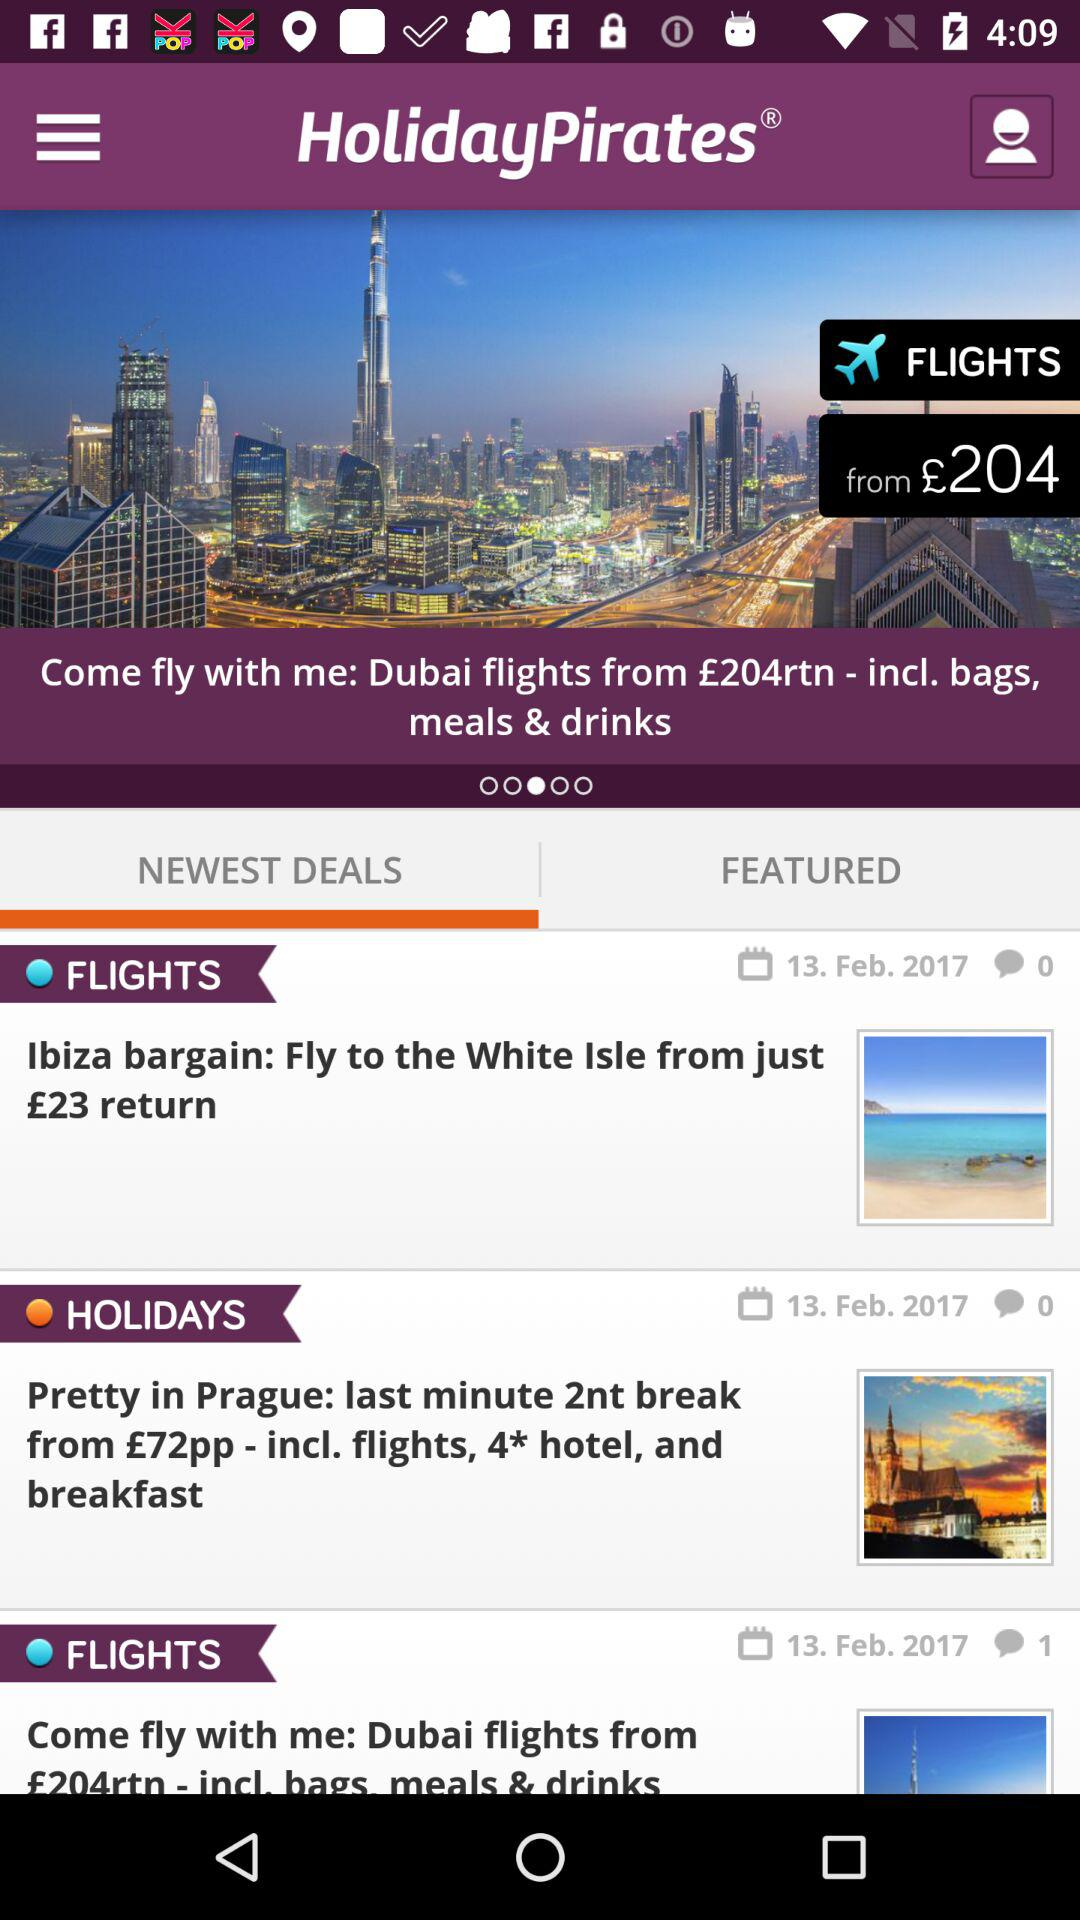How many offers are there in total?
Answer the question using a single word or phrase. 3 